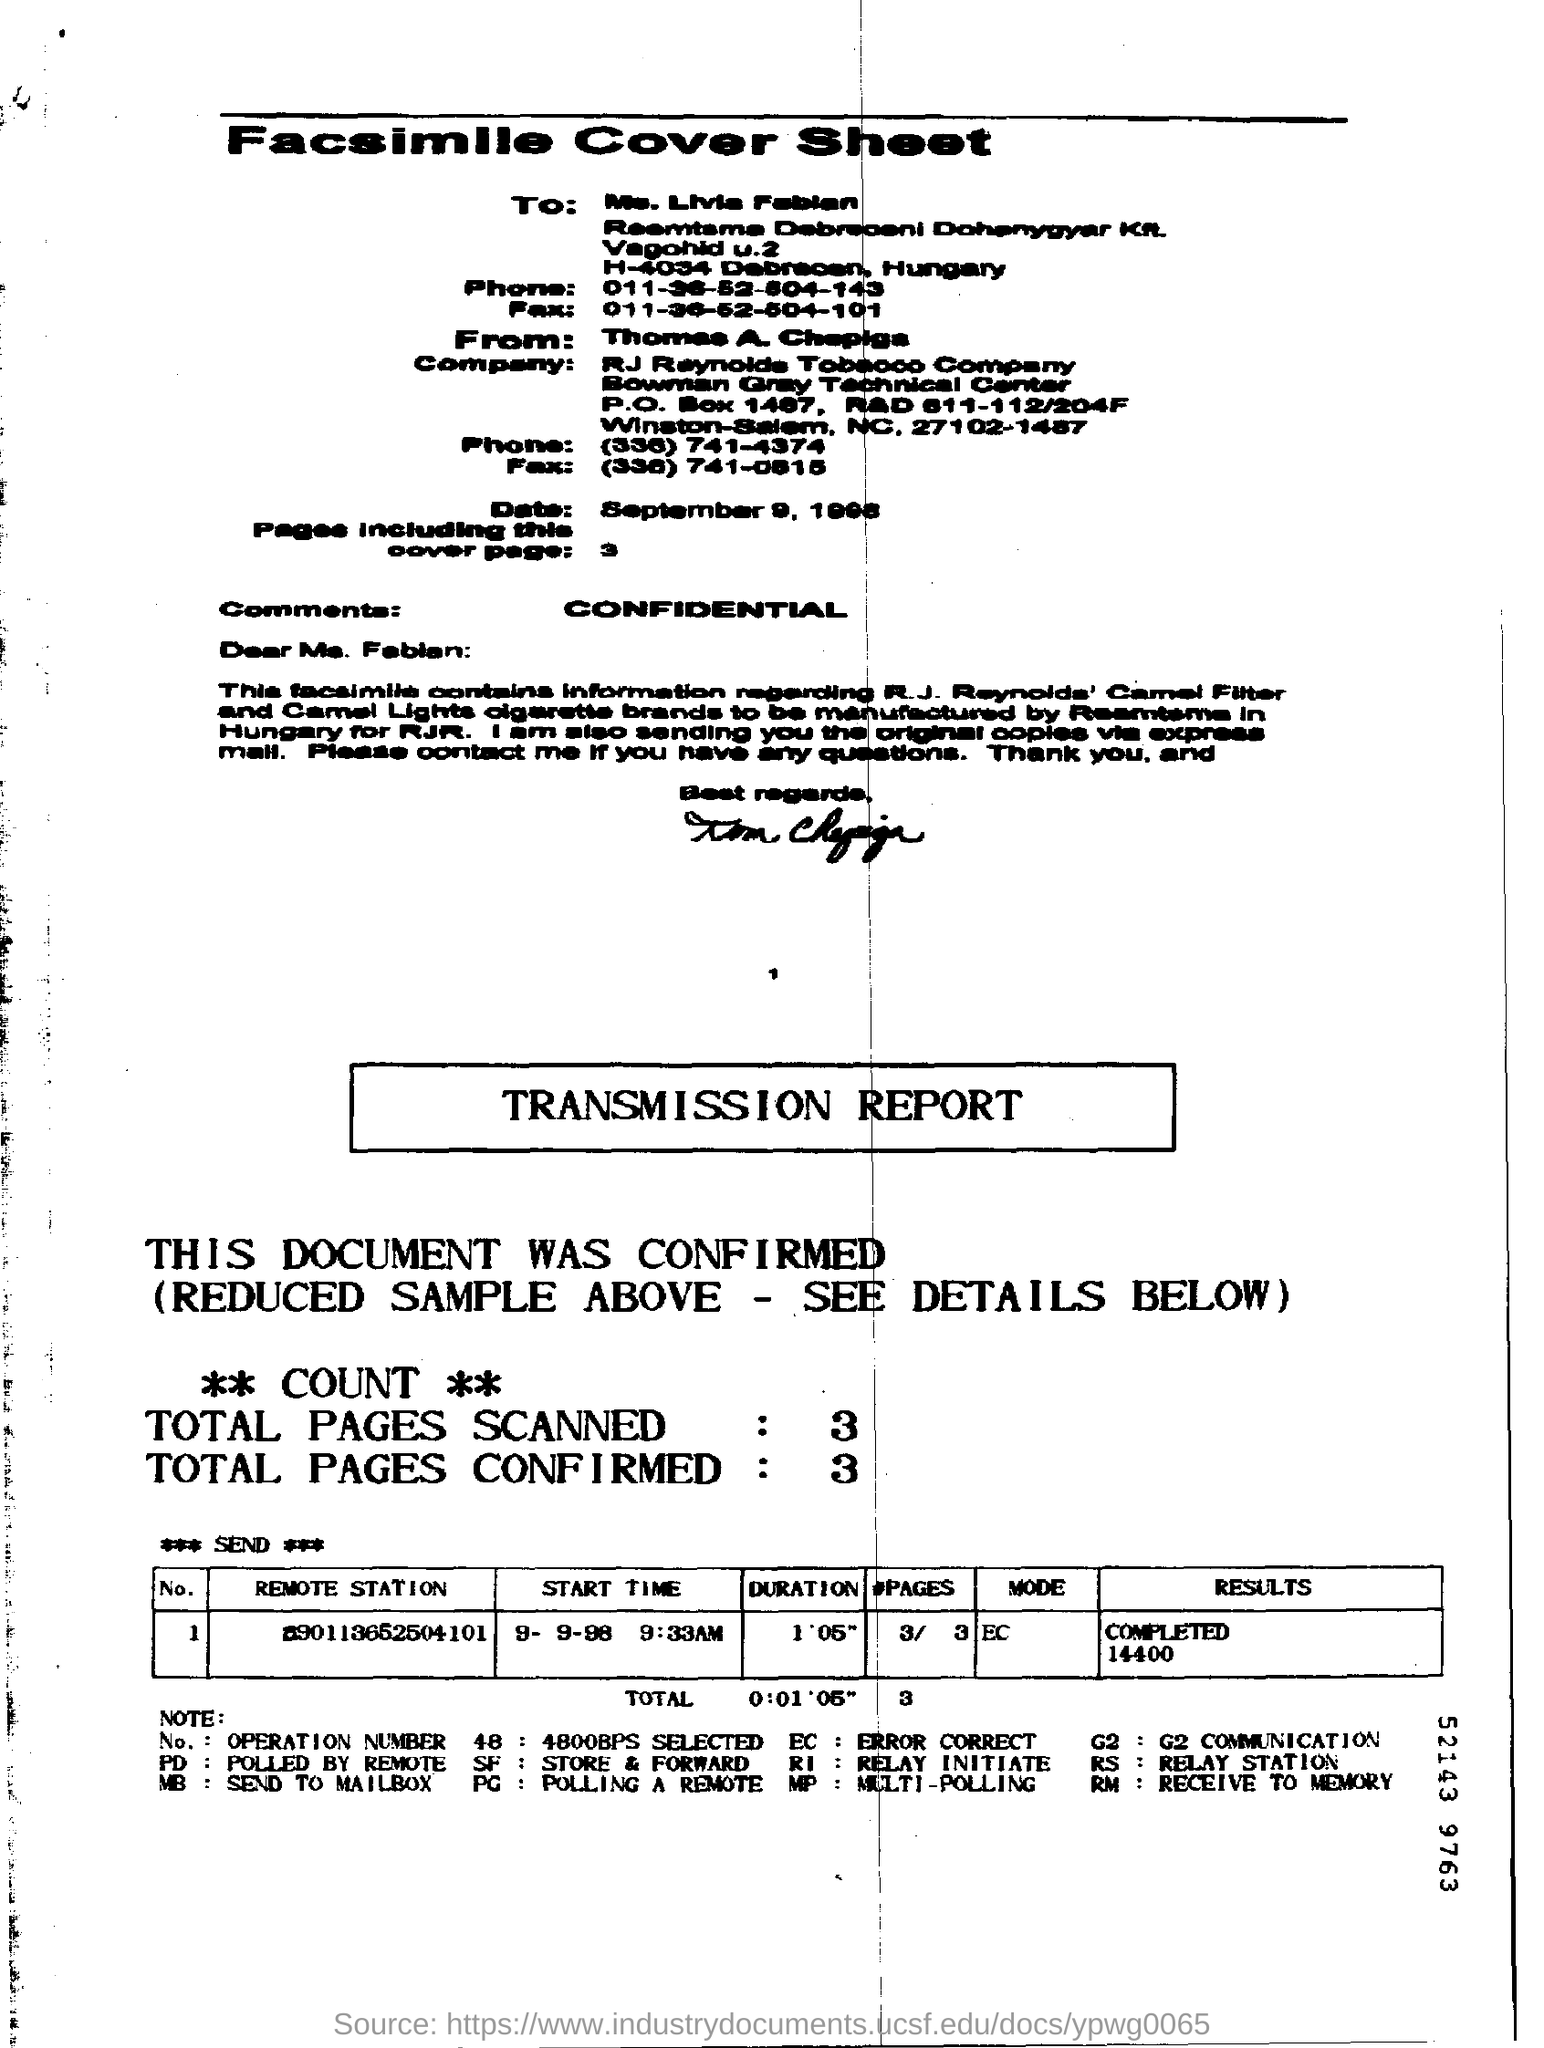What is written as comments?
Make the answer very short. Confidential. Number of pages including this cover page?
Offer a very short reply. 3. 